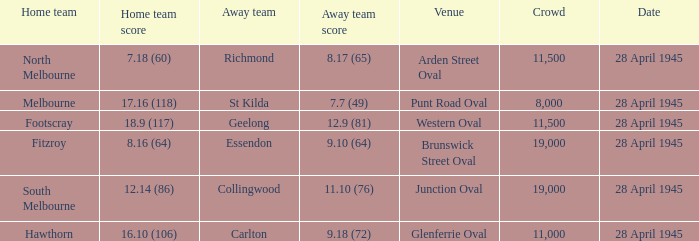What away team played at western oval? Geelong. 